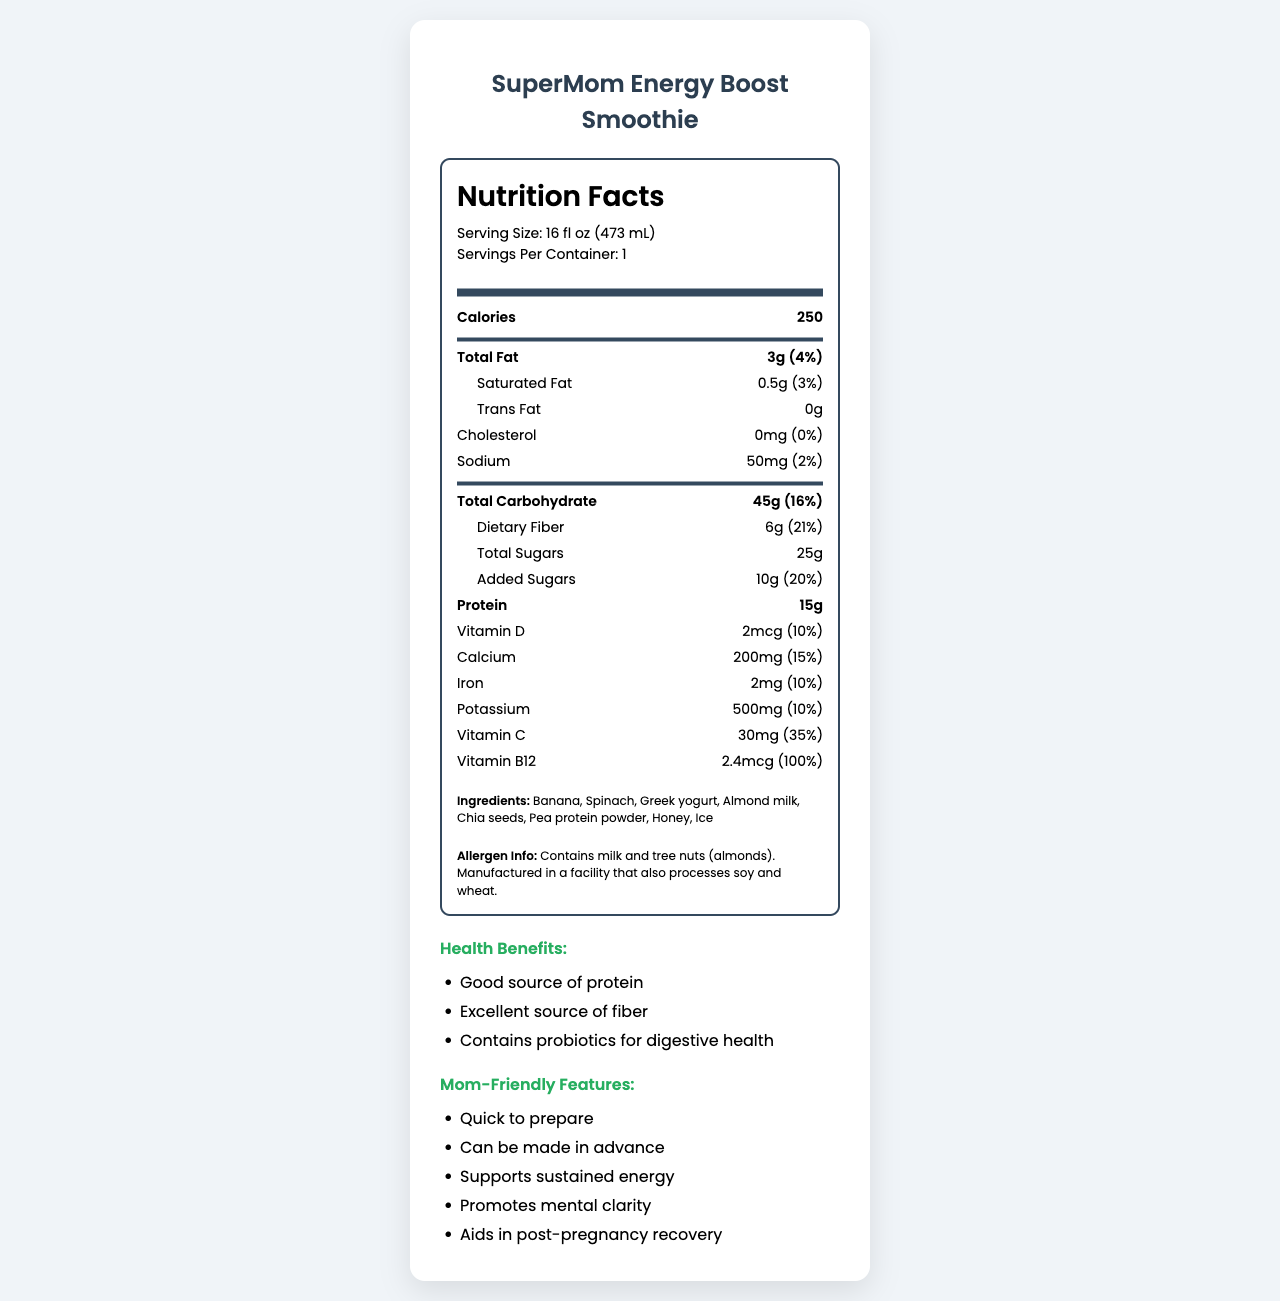what is the serving size for the SuperMom Energy Boost Smoothie? The document states the serving size directly under the product name and nutrition title.
Answer: 16 fl oz (473 mL) how many servings per container? The document lists servings per container as 1 right next to the serving size.
Answer: 1 how many calories per serving? The number of calories per serving is displayed at the top of the nutritional facts section.
Answer: 250 how much total fat is in one smoothie? The total fat content is 3g, which is 4% of the daily value.
Answer: 3g (4% DV) how much added sugars are in the smoothie? The document states that there are 10g of added sugars, which is 20% of the daily value.
Answer: 10g (20% DV) how much protein is in the smoothie? The document lists the protein content as 15g.
Answer: 15g what is the amount of dietary fiber in a serving? Dietary fiber is 6g per serving, which is 21% of the daily value.
Answer: 6g (21% DV) does the smoothie contain any trans fat? The document states "Trans Fat: 0g", meaning there are no trans fats in the smoothie.
Answer: No what are the main ingredients in the SuperMom Energy Boost Smoothie? The ingredients are listed in the document's ingredients section.
Answer: Banana, Spinach, Greek yogurt, Almond milk, Chia seeds, Pea protein powder, Honey, Ice what are the mom-friendly features of this smoothie? The document lists these features in the mom-friendly section.
Answer: Quick to prepare, Can be made in advance, Supports sustained energy, Promotes mental clarity, Aids in post-pregnancy recovery which vitamin is present in the highest daily value percentage? A. Vitamin D B. Vitamin B12 C. Vitamin C D. Potassium Vitamin B12 is listed as 100% of the daily value, the highest percentage among the listed vitamins and minerals.
Answer: B. Vitamin B12 how much calcium does one serving provide? A. 100mg B. 200mg C. 300mg D. 400mg The document lists calcium content as 200mg per serving.
Answer: B. 200mg does the smoothie contain any common allergens? The document states that it contains milk and tree nuts (almonds).
Answer: Yes what is the recommended storage instruction for this smoothie? The storage instructions are listed in the document's storage section.
Answer: Keep refrigerated. Consume within 24 hours of preparation for best quality and nutritional value. is the smoothie a good source of fiber? The document claims that it is an "Excellent source of fiber."
Answer: Yes what is the main idea of the document? The document includes various sections describing the smoothie from nutritional facts to specific benefits for mothers and practical instructions.
Answer: The document provides detailed nutritional information, ingredient list, health benefits, mom-friendly features, allergen information, and preparation/storage instructions for the SuperMom Energy Boost Smoothie. what is the manufacturing process of the smoothie? The document does not provide details on the manufacturing process of the smoothie.
Answer: Not enough information 